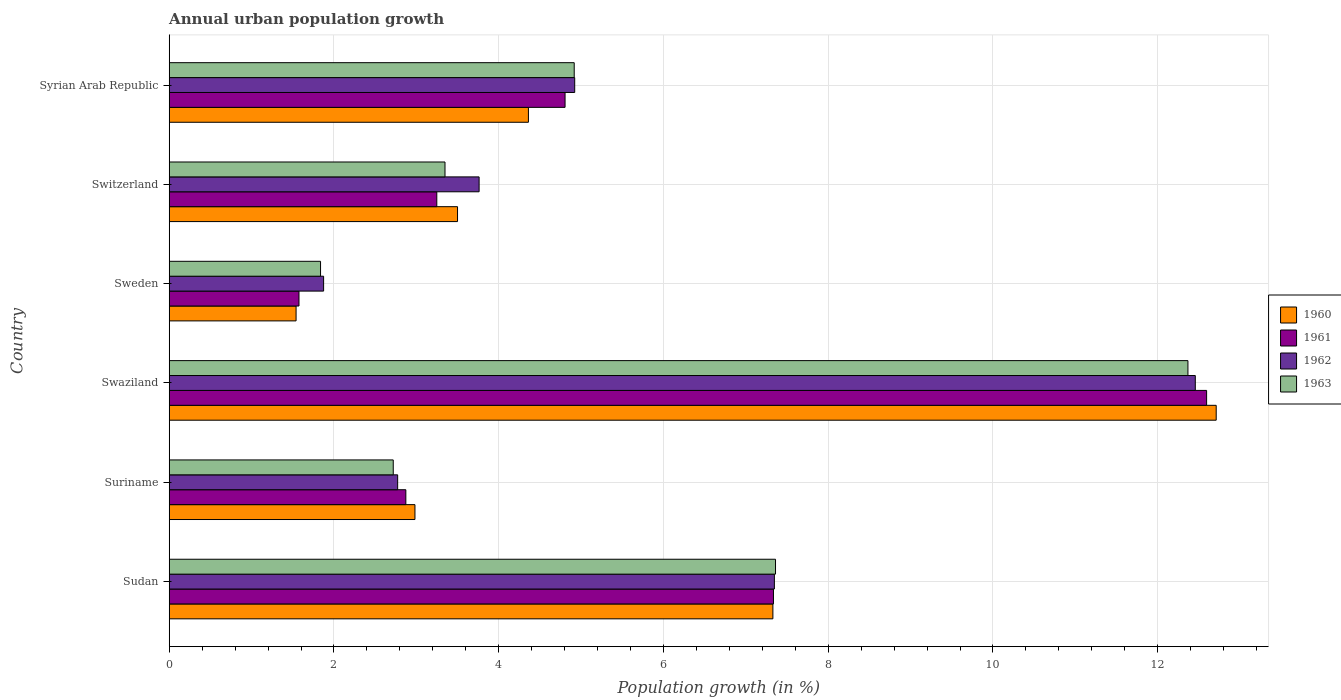Are the number of bars per tick equal to the number of legend labels?
Provide a succinct answer. Yes. How many bars are there on the 6th tick from the bottom?
Give a very brief answer. 4. What is the label of the 6th group of bars from the top?
Your answer should be compact. Sudan. What is the percentage of urban population growth in 1962 in Sweden?
Offer a very short reply. 1.87. Across all countries, what is the maximum percentage of urban population growth in 1963?
Ensure brevity in your answer.  12.37. Across all countries, what is the minimum percentage of urban population growth in 1962?
Your answer should be very brief. 1.87. In which country was the percentage of urban population growth in 1961 maximum?
Ensure brevity in your answer.  Swaziland. In which country was the percentage of urban population growth in 1960 minimum?
Provide a succinct answer. Sweden. What is the total percentage of urban population growth in 1960 in the graph?
Provide a succinct answer. 32.42. What is the difference between the percentage of urban population growth in 1963 in Suriname and that in Switzerland?
Your answer should be very brief. -0.63. What is the difference between the percentage of urban population growth in 1960 in Syrian Arab Republic and the percentage of urban population growth in 1963 in Swaziland?
Your answer should be very brief. -8.01. What is the average percentage of urban population growth in 1962 per country?
Offer a very short reply. 5.52. What is the difference between the percentage of urban population growth in 1962 and percentage of urban population growth in 1961 in Suriname?
Your response must be concise. -0.1. What is the ratio of the percentage of urban population growth in 1963 in Sudan to that in Syrian Arab Republic?
Give a very brief answer. 1.5. Is the percentage of urban population growth in 1961 in Sudan less than that in Swaziland?
Keep it short and to the point. Yes. What is the difference between the highest and the second highest percentage of urban population growth in 1963?
Make the answer very short. 5.01. What is the difference between the highest and the lowest percentage of urban population growth in 1962?
Offer a very short reply. 10.58. Is it the case that in every country, the sum of the percentage of urban population growth in 1962 and percentage of urban population growth in 1960 is greater than the percentage of urban population growth in 1961?
Provide a short and direct response. Yes. Are all the bars in the graph horizontal?
Give a very brief answer. Yes. How many countries are there in the graph?
Make the answer very short. 6. Are the values on the major ticks of X-axis written in scientific E-notation?
Your response must be concise. No. Does the graph contain any zero values?
Offer a terse response. No. How many legend labels are there?
Make the answer very short. 4. How are the legend labels stacked?
Offer a very short reply. Vertical. What is the title of the graph?
Your response must be concise. Annual urban population growth. What is the label or title of the X-axis?
Provide a succinct answer. Population growth (in %). What is the Population growth (in %) of 1960 in Sudan?
Your answer should be very brief. 7.33. What is the Population growth (in %) of 1961 in Sudan?
Your answer should be very brief. 7.34. What is the Population growth (in %) in 1962 in Sudan?
Your answer should be compact. 7.35. What is the Population growth (in %) of 1963 in Sudan?
Your answer should be very brief. 7.36. What is the Population growth (in %) of 1960 in Suriname?
Give a very brief answer. 2.98. What is the Population growth (in %) in 1961 in Suriname?
Offer a terse response. 2.87. What is the Population growth (in %) of 1962 in Suriname?
Offer a terse response. 2.77. What is the Population growth (in %) in 1963 in Suriname?
Make the answer very short. 2.72. What is the Population growth (in %) of 1960 in Swaziland?
Your answer should be compact. 12.71. What is the Population growth (in %) of 1961 in Swaziland?
Provide a succinct answer. 12.59. What is the Population growth (in %) in 1962 in Swaziland?
Your answer should be very brief. 12.46. What is the Population growth (in %) in 1963 in Swaziland?
Your response must be concise. 12.37. What is the Population growth (in %) of 1960 in Sweden?
Provide a short and direct response. 1.54. What is the Population growth (in %) in 1961 in Sweden?
Keep it short and to the point. 1.58. What is the Population growth (in %) in 1962 in Sweden?
Offer a terse response. 1.87. What is the Population growth (in %) in 1963 in Sweden?
Make the answer very short. 1.84. What is the Population growth (in %) in 1960 in Switzerland?
Offer a very short reply. 3.5. What is the Population growth (in %) of 1961 in Switzerland?
Offer a very short reply. 3.25. What is the Population growth (in %) in 1962 in Switzerland?
Provide a succinct answer. 3.76. What is the Population growth (in %) in 1963 in Switzerland?
Your answer should be compact. 3.35. What is the Population growth (in %) in 1960 in Syrian Arab Republic?
Offer a terse response. 4.36. What is the Population growth (in %) of 1961 in Syrian Arab Republic?
Provide a succinct answer. 4.81. What is the Population growth (in %) of 1962 in Syrian Arab Republic?
Give a very brief answer. 4.92. What is the Population growth (in %) of 1963 in Syrian Arab Republic?
Offer a terse response. 4.92. Across all countries, what is the maximum Population growth (in %) of 1960?
Your answer should be very brief. 12.71. Across all countries, what is the maximum Population growth (in %) in 1961?
Keep it short and to the point. 12.59. Across all countries, what is the maximum Population growth (in %) of 1962?
Ensure brevity in your answer.  12.46. Across all countries, what is the maximum Population growth (in %) of 1963?
Keep it short and to the point. 12.37. Across all countries, what is the minimum Population growth (in %) of 1960?
Your answer should be compact. 1.54. Across all countries, what is the minimum Population growth (in %) of 1961?
Give a very brief answer. 1.58. Across all countries, what is the minimum Population growth (in %) in 1962?
Provide a succinct answer. 1.87. Across all countries, what is the minimum Population growth (in %) of 1963?
Your answer should be very brief. 1.84. What is the total Population growth (in %) of 1960 in the graph?
Provide a short and direct response. 32.42. What is the total Population growth (in %) of 1961 in the graph?
Offer a terse response. 32.43. What is the total Population growth (in %) in 1962 in the graph?
Your answer should be very brief. 33.14. What is the total Population growth (in %) in 1963 in the graph?
Provide a short and direct response. 32.55. What is the difference between the Population growth (in %) in 1960 in Sudan and that in Suriname?
Provide a succinct answer. 4.35. What is the difference between the Population growth (in %) of 1961 in Sudan and that in Suriname?
Your answer should be very brief. 4.46. What is the difference between the Population growth (in %) in 1962 in Sudan and that in Suriname?
Keep it short and to the point. 4.57. What is the difference between the Population growth (in %) in 1963 in Sudan and that in Suriname?
Offer a terse response. 4.64. What is the difference between the Population growth (in %) in 1960 in Sudan and that in Swaziland?
Make the answer very short. -5.38. What is the difference between the Population growth (in %) of 1961 in Sudan and that in Swaziland?
Your answer should be very brief. -5.26. What is the difference between the Population growth (in %) of 1962 in Sudan and that in Swaziland?
Your answer should be compact. -5.11. What is the difference between the Population growth (in %) in 1963 in Sudan and that in Swaziland?
Provide a succinct answer. -5.01. What is the difference between the Population growth (in %) in 1960 in Sudan and that in Sweden?
Give a very brief answer. 5.79. What is the difference between the Population growth (in %) of 1961 in Sudan and that in Sweden?
Provide a short and direct response. 5.76. What is the difference between the Population growth (in %) in 1962 in Sudan and that in Sweden?
Offer a terse response. 5.47. What is the difference between the Population growth (in %) in 1963 in Sudan and that in Sweden?
Your response must be concise. 5.52. What is the difference between the Population growth (in %) of 1960 in Sudan and that in Switzerland?
Give a very brief answer. 3.83. What is the difference between the Population growth (in %) in 1961 in Sudan and that in Switzerland?
Keep it short and to the point. 4.09. What is the difference between the Population growth (in %) in 1962 in Sudan and that in Switzerland?
Provide a short and direct response. 3.58. What is the difference between the Population growth (in %) of 1963 in Sudan and that in Switzerland?
Offer a very short reply. 4.01. What is the difference between the Population growth (in %) in 1960 in Sudan and that in Syrian Arab Republic?
Provide a succinct answer. 2.97. What is the difference between the Population growth (in %) in 1961 in Sudan and that in Syrian Arab Republic?
Offer a terse response. 2.53. What is the difference between the Population growth (in %) of 1962 in Sudan and that in Syrian Arab Republic?
Give a very brief answer. 2.42. What is the difference between the Population growth (in %) in 1963 in Sudan and that in Syrian Arab Republic?
Provide a succinct answer. 2.44. What is the difference between the Population growth (in %) of 1960 in Suriname and that in Swaziland?
Your answer should be compact. -9.73. What is the difference between the Population growth (in %) in 1961 in Suriname and that in Swaziland?
Ensure brevity in your answer.  -9.72. What is the difference between the Population growth (in %) in 1962 in Suriname and that in Swaziland?
Provide a short and direct response. -9.68. What is the difference between the Population growth (in %) in 1963 in Suriname and that in Swaziland?
Your answer should be very brief. -9.65. What is the difference between the Population growth (in %) in 1960 in Suriname and that in Sweden?
Offer a very short reply. 1.44. What is the difference between the Population growth (in %) in 1961 in Suriname and that in Sweden?
Provide a short and direct response. 1.3. What is the difference between the Population growth (in %) in 1962 in Suriname and that in Sweden?
Offer a terse response. 0.9. What is the difference between the Population growth (in %) in 1963 in Suriname and that in Sweden?
Provide a short and direct response. 0.88. What is the difference between the Population growth (in %) in 1960 in Suriname and that in Switzerland?
Offer a very short reply. -0.52. What is the difference between the Population growth (in %) in 1961 in Suriname and that in Switzerland?
Offer a very short reply. -0.38. What is the difference between the Population growth (in %) in 1962 in Suriname and that in Switzerland?
Your response must be concise. -0.99. What is the difference between the Population growth (in %) in 1963 in Suriname and that in Switzerland?
Ensure brevity in your answer.  -0.63. What is the difference between the Population growth (in %) in 1960 in Suriname and that in Syrian Arab Republic?
Provide a succinct answer. -1.38. What is the difference between the Population growth (in %) of 1961 in Suriname and that in Syrian Arab Republic?
Your answer should be very brief. -1.93. What is the difference between the Population growth (in %) of 1962 in Suriname and that in Syrian Arab Republic?
Your answer should be very brief. -2.15. What is the difference between the Population growth (in %) in 1963 in Suriname and that in Syrian Arab Republic?
Give a very brief answer. -2.2. What is the difference between the Population growth (in %) of 1960 in Swaziland and that in Sweden?
Offer a very short reply. 11.17. What is the difference between the Population growth (in %) of 1961 in Swaziland and that in Sweden?
Give a very brief answer. 11.02. What is the difference between the Population growth (in %) of 1962 in Swaziland and that in Sweden?
Provide a short and direct response. 10.58. What is the difference between the Population growth (in %) of 1963 in Swaziland and that in Sweden?
Your answer should be very brief. 10.53. What is the difference between the Population growth (in %) in 1960 in Swaziland and that in Switzerland?
Ensure brevity in your answer.  9.21. What is the difference between the Population growth (in %) in 1961 in Swaziland and that in Switzerland?
Offer a very short reply. 9.35. What is the difference between the Population growth (in %) of 1962 in Swaziland and that in Switzerland?
Your response must be concise. 8.69. What is the difference between the Population growth (in %) in 1963 in Swaziland and that in Switzerland?
Ensure brevity in your answer.  9.02. What is the difference between the Population growth (in %) in 1960 in Swaziland and that in Syrian Arab Republic?
Offer a very short reply. 8.35. What is the difference between the Population growth (in %) of 1961 in Swaziland and that in Syrian Arab Republic?
Your answer should be very brief. 7.79. What is the difference between the Population growth (in %) of 1962 in Swaziland and that in Syrian Arab Republic?
Make the answer very short. 7.53. What is the difference between the Population growth (in %) in 1963 in Swaziland and that in Syrian Arab Republic?
Ensure brevity in your answer.  7.45. What is the difference between the Population growth (in %) of 1960 in Sweden and that in Switzerland?
Offer a very short reply. -1.96. What is the difference between the Population growth (in %) in 1961 in Sweden and that in Switzerland?
Your response must be concise. -1.67. What is the difference between the Population growth (in %) of 1962 in Sweden and that in Switzerland?
Give a very brief answer. -1.89. What is the difference between the Population growth (in %) of 1963 in Sweden and that in Switzerland?
Ensure brevity in your answer.  -1.51. What is the difference between the Population growth (in %) in 1960 in Sweden and that in Syrian Arab Republic?
Your answer should be compact. -2.82. What is the difference between the Population growth (in %) of 1961 in Sweden and that in Syrian Arab Republic?
Your response must be concise. -3.23. What is the difference between the Population growth (in %) of 1962 in Sweden and that in Syrian Arab Republic?
Give a very brief answer. -3.05. What is the difference between the Population growth (in %) of 1963 in Sweden and that in Syrian Arab Republic?
Your answer should be very brief. -3.08. What is the difference between the Population growth (in %) of 1960 in Switzerland and that in Syrian Arab Republic?
Make the answer very short. -0.86. What is the difference between the Population growth (in %) of 1961 in Switzerland and that in Syrian Arab Republic?
Give a very brief answer. -1.56. What is the difference between the Population growth (in %) in 1962 in Switzerland and that in Syrian Arab Republic?
Your response must be concise. -1.16. What is the difference between the Population growth (in %) in 1963 in Switzerland and that in Syrian Arab Republic?
Your answer should be compact. -1.57. What is the difference between the Population growth (in %) of 1960 in Sudan and the Population growth (in %) of 1961 in Suriname?
Give a very brief answer. 4.46. What is the difference between the Population growth (in %) in 1960 in Sudan and the Population growth (in %) in 1962 in Suriname?
Your response must be concise. 4.56. What is the difference between the Population growth (in %) of 1960 in Sudan and the Population growth (in %) of 1963 in Suriname?
Provide a succinct answer. 4.61. What is the difference between the Population growth (in %) of 1961 in Sudan and the Population growth (in %) of 1962 in Suriname?
Offer a very short reply. 4.56. What is the difference between the Population growth (in %) in 1961 in Sudan and the Population growth (in %) in 1963 in Suriname?
Your response must be concise. 4.62. What is the difference between the Population growth (in %) in 1962 in Sudan and the Population growth (in %) in 1963 in Suriname?
Your answer should be very brief. 4.63. What is the difference between the Population growth (in %) of 1960 in Sudan and the Population growth (in %) of 1961 in Swaziland?
Provide a succinct answer. -5.27. What is the difference between the Population growth (in %) of 1960 in Sudan and the Population growth (in %) of 1962 in Swaziland?
Your answer should be compact. -5.13. What is the difference between the Population growth (in %) in 1960 in Sudan and the Population growth (in %) in 1963 in Swaziland?
Offer a terse response. -5.04. What is the difference between the Population growth (in %) of 1961 in Sudan and the Population growth (in %) of 1962 in Swaziland?
Ensure brevity in your answer.  -5.12. What is the difference between the Population growth (in %) in 1961 in Sudan and the Population growth (in %) in 1963 in Swaziland?
Make the answer very short. -5.03. What is the difference between the Population growth (in %) in 1962 in Sudan and the Population growth (in %) in 1963 in Swaziland?
Your answer should be very brief. -5.02. What is the difference between the Population growth (in %) in 1960 in Sudan and the Population growth (in %) in 1961 in Sweden?
Make the answer very short. 5.75. What is the difference between the Population growth (in %) in 1960 in Sudan and the Population growth (in %) in 1962 in Sweden?
Your response must be concise. 5.45. What is the difference between the Population growth (in %) in 1960 in Sudan and the Population growth (in %) in 1963 in Sweden?
Keep it short and to the point. 5.49. What is the difference between the Population growth (in %) of 1961 in Sudan and the Population growth (in %) of 1962 in Sweden?
Ensure brevity in your answer.  5.46. What is the difference between the Population growth (in %) in 1961 in Sudan and the Population growth (in %) in 1963 in Sweden?
Offer a terse response. 5.5. What is the difference between the Population growth (in %) in 1962 in Sudan and the Population growth (in %) in 1963 in Sweden?
Give a very brief answer. 5.51. What is the difference between the Population growth (in %) of 1960 in Sudan and the Population growth (in %) of 1961 in Switzerland?
Your answer should be compact. 4.08. What is the difference between the Population growth (in %) of 1960 in Sudan and the Population growth (in %) of 1962 in Switzerland?
Ensure brevity in your answer.  3.57. What is the difference between the Population growth (in %) in 1960 in Sudan and the Population growth (in %) in 1963 in Switzerland?
Your answer should be compact. 3.98. What is the difference between the Population growth (in %) of 1961 in Sudan and the Population growth (in %) of 1962 in Switzerland?
Give a very brief answer. 3.57. What is the difference between the Population growth (in %) of 1961 in Sudan and the Population growth (in %) of 1963 in Switzerland?
Offer a terse response. 3.99. What is the difference between the Population growth (in %) in 1962 in Sudan and the Population growth (in %) in 1963 in Switzerland?
Keep it short and to the point. 4. What is the difference between the Population growth (in %) in 1960 in Sudan and the Population growth (in %) in 1961 in Syrian Arab Republic?
Provide a succinct answer. 2.52. What is the difference between the Population growth (in %) of 1960 in Sudan and the Population growth (in %) of 1962 in Syrian Arab Republic?
Offer a very short reply. 2.41. What is the difference between the Population growth (in %) in 1960 in Sudan and the Population growth (in %) in 1963 in Syrian Arab Republic?
Keep it short and to the point. 2.41. What is the difference between the Population growth (in %) in 1961 in Sudan and the Population growth (in %) in 1962 in Syrian Arab Republic?
Make the answer very short. 2.41. What is the difference between the Population growth (in %) of 1961 in Sudan and the Population growth (in %) of 1963 in Syrian Arab Republic?
Your response must be concise. 2.42. What is the difference between the Population growth (in %) in 1962 in Sudan and the Population growth (in %) in 1963 in Syrian Arab Republic?
Ensure brevity in your answer.  2.43. What is the difference between the Population growth (in %) in 1960 in Suriname and the Population growth (in %) in 1961 in Swaziland?
Ensure brevity in your answer.  -9.61. What is the difference between the Population growth (in %) of 1960 in Suriname and the Population growth (in %) of 1962 in Swaziland?
Your answer should be compact. -9.47. What is the difference between the Population growth (in %) of 1960 in Suriname and the Population growth (in %) of 1963 in Swaziland?
Ensure brevity in your answer.  -9.38. What is the difference between the Population growth (in %) of 1961 in Suriname and the Population growth (in %) of 1962 in Swaziland?
Your answer should be very brief. -9.58. What is the difference between the Population growth (in %) in 1961 in Suriname and the Population growth (in %) in 1963 in Swaziland?
Your answer should be very brief. -9.49. What is the difference between the Population growth (in %) in 1962 in Suriname and the Population growth (in %) in 1963 in Swaziland?
Provide a short and direct response. -9.59. What is the difference between the Population growth (in %) in 1960 in Suriname and the Population growth (in %) in 1961 in Sweden?
Provide a short and direct response. 1.41. What is the difference between the Population growth (in %) of 1960 in Suriname and the Population growth (in %) of 1962 in Sweden?
Give a very brief answer. 1.11. What is the difference between the Population growth (in %) in 1960 in Suriname and the Population growth (in %) in 1963 in Sweden?
Provide a short and direct response. 1.15. What is the difference between the Population growth (in %) of 1961 in Suriname and the Population growth (in %) of 1962 in Sweden?
Provide a succinct answer. 1. What is the difference between the Population growth (in %) in 1961 in Suriname and the Population growth (in %) in 1963 in Sweden?
Offer a very short reply. 1.04. What is the difference between the Population growth (in %) in 1962 in Suriname and the Population growth (in %) in 1963 in Sweden?
Offer a very short reply. 0.94. What is the difference between the Population growth (in %) of 1960 in Suriname and the Population growth (in %) of 1961 in Switzerland?
Provide a succinct answer. -0.27. What is the difference between the Population growth (in %) in 1960 in Suriname and the Population growth (in %) in 1962 in Switzerland?
Your response must be concise. -0.78. What is the difference between the Population growth (in %) of 1960 in Suriname and the Population growth (in %) of 1963 in Switzerland?
Keep it short and to the point. -0.36. What is the difference between the Population growth (in %) in 1961 in Suriname and the Population growth (in %) in 1962 in Switzerland?
Make the answer very short. -0.89. What is the difference between the Population growth (in %) of 1961 in Suriname and the Population growth (in %) of 1963 in Switzerland?
Offer a very short reply. -0.48. What is the difference between the Population growth (in %) in 1962 in Suriname and the Population growth (in %) in 1963 in Switzerland?
Provide a succinct answer. -0.57. What is the difference between the Population growth (in %) of 1960 in Suriname and the Population growth (in %) of 1961 in Syrian Arab Republic?
Your answer should be very brief. -1.82. What is the difference between the Population growth (in %) in 1960 in Suriname and the Population growth (in %) in 1962 in Syrian Arab Republic?
Your answer should be very brief. -1.94. What is the difference between the Population growth (in %) of 1960 in Suriname and the Population growth (in %) of 1963 in Syrian Arab Republic?
Ensure brevity in your answer.  -1.93. What is the difference between the Population growth (in %) of 1961 in Suriname and the Population growth (in %) of 1962 in Syrian Arab Republic?
Your answer should be compact. -2.05. What is the difference between the Population growth (in %) of 1961 in Suriname and the Population growth (in %) of 1963 in Syrian Arab Republic?
Offer a very short reply. -2.04. What is the difference between the Population growth (in %) of 1962 in Suriname and the Population growth (in %) of 1963 in Syrian Arab Republic?
Ensure brevity in your answer.  -2.14. What is the difference between the Population growth (in %) of 1960 in Swaziland and the Population growth (in %) of 1961 in Sweden?
Give a very brief answer. 11.13. What is the difference between the Population growth (in %) of 1960 in Swaziland and the Population growth (in %) of 1962 in Sweden?
Your answer should be very brief. 10.84. What is the difference between the Population growth (in %) in 1960 in Swaziland and the Population growth (in %) in 1963 in Sweden?
Your answer should be very brief. 10.87. What is the difference between the Population growth (in %) in 1961 in Swaziland and the Population growth (in %) in 1962 in Sweden?
Your answer should be compact. 10.72. What is the difference between the Population growth (in %) of 1961 in Swaziland and the Population growth (in %) of 1963 in Sweden?
Give a very brief answer. 10.76. What is the difference between the Population growth (in %) of 1962 in Swaziland and the Population growth (in %) of 1963 in Sweden?
Offer a very short reply. 10.62. What is the difference between the Population growth (in %) of 1960 in Swaziland and the Population growth (in %) of 1961 in Switzerland?
Give a very brief answer. 9.46. What is the difference between the Population growth (in %) of 1960 in Swaziland and the Population growth (in %) of 1962 in Switzerland?
Provide a succinct answer. 8.95. What is the difference between the Population growth (in %) of 1960 in Swaziland and the Population growth (in %) of 1963 in Switzerland?
Give a very brief answer. 9.36. What is the difference between the Population growth (in %) in 1961 in Swaziland and the Population growth (in %) in 1962 in Switzerland?
Provide a short and direct response. 8.83. What is the difference between the Population growth (in %) in 1961 in Swaziland and the Population growth (in %) in 1963 in Switzerland?
Your response must be concise. 9.25. What is the difference between the Population growth (in %) in 1962 in Swaziland and the Population growth (in %) in 1963 in Switzerland?
Your answer should be compact. 9.11. What is the difference between the Population growth (in %) in 1960 in Swaziland and the Population growth (in %) in 1961 in Syrian Arab Republic?
Offer a very short reply. 7.9. What is the difference between the Population growth (in %) in 1960 in Swaziland and the Population growth (in %) in 1962 in Syrian Arab Republic?
Provide a succinct answer. 7.79. What is the difference between the Population growth (in %) in 1960 in Swaziland and the Population growth (in %) in 1963 in Syrian Arab Republic?
Your answer should be very brief. 7.79. What is the difference between the Population growth (in %) of 1961 in Swaziland and the Population growth (in %) of 1962 in Syrian Arab Republic?
Give a very brief answer. 7.67. What is the difference between the Population growth (in %) in 1961 in Swaziland and the Population growth (in %) in 1963 in Syrian Arab Republic?
Your response must be concise. 7.68. What is the difference between the Population growth (in %) of 1962 in Swaziland and the Population growth (in %) of 1963 in Syrian Arab Republic?
Offer a terse response. 7.54. What is the difference between the Population growth (in %) of 1960 in Sweden and the Population growth (in %) of 1961 in Switzerland?
Your answer should be compact. -1.71. What is the difference between the Population growth (in %) of 1960 in Sweden and the Population growth (in %) of 1962 in Switzerland?
Ensure brevity in your answer.  -2.22. What is the difference between the Population growth (in %) of 1960 in Sweden and the Population growth (in %) of 1963 in Switzerland?
Provide a short and direct response. -1.81. What is the difference between the Population growth (in %) of 1961 in Sweden and the Population growth (in %) of 1962 in Switzerland?
Offer a very short reply. -2.19. What is the difference between the Population growth (in %) of 1961 in Sweden and the Population growth (in %) of 1963 in Switzerland?
Your response must be concise. -1.77. What is the difference between the Population growth (in %) of 1962 in Sweden and the Population growth (in %) of 1963 in Switzerland?
Provide a short and direct response. -1.47. What is the difference between the Population growth (in %) of 1960 in Sweden and the Population growth (in %) of 1961 in Syrian Arab Republic?
Your answer should be very brief. -3.27. What is the difference between the Population growth (in %) of 1960 in Sweden and the Population growth (in %) of 1962 in Syrian Arab Republic?
Make the answer very short. -3.38. What is the difference between the Population growth (in %) of 1960 in Sweden and the Population growth (in %) of 1963 in Syrian Arab Republic?
Your response must be concise. -3.38. What is the difference between the Population growth (in %) of 1961 in Sweden and the Population growth (in %) of 1962 in Syrian Arab Republic?
Provide a succinct answer. -3.35. What is the difference between the Population growth (in %) in 1961 in Sweden and the Population growth (in %) in 1963 in Syrian Arab Republic?
Give a very brief answer. -3.34. What is the difference between the Population growth (in %) in 1962 in Sweden and the Population growth (in %) in 1963 in Syrian Arab Republic?
Make the answer very short. -3.04. What is the difference between the Population growth (in %) of 1960 in Switzerland and the Population growth (in %) of 1961 in Syrian Arab Republic?
Your answer should be compact. -1.31. What is the difference between the Population growth (in %) in 1960 in Switzerland and the Population growth (in %) in 1962 in Syrian Arab Republic?
Give a very brief answer. -1.42. What is the difference between the Population growth (in %) in 1960 in Switzerland and the Population growth (in %) in 1963 in Syrian Arab Republic?
Make the answer very short. -1.42. What is the difference between the Population growth (in %) in 1961 in Switzerland and the Population growth (in %) in 1962 in Syrian Arab Republic?
Ensure brevity in your answer.  -1.67. What is the difference between the Population growth (in %) of 1961 in Switzerland and the Population growth (in %) of 1963 in Syrian Arab Republic?
Provide a succinct answer. -1.67. What is the difference between the Population growth (in %) in 1962 in Switzerland and the Population growth (in %) in 1963 in Syrian Arab Republic?
Provide a succinct answer. -1.15. What is the average Population growth (in %) of 1960 per country?
Give a very brief answer. 5.4. What is the average Population growth (in %) of 1961 per country?
Offer a terse response. 5.41. What is the average Population growth (in %) of 1962 per country?
Provide a succinct answer. 5.52. What is the average Population growth (in %) of 1963 per country?
Offer a very short reply. 5.42. What is the difference between the Population growth (in %) in 1960 and Population growth (in %) in 1961 in Sudan?
Your answer should be compact. -0.01. What is the difference between the Population growth (in %) of 1960 and Population growth (in %) of 1962 in Sudan?
Give a very brief answer. -0.02. What is the difference between the Population growth (in %) in 1960 and Population growth (in %) in 1963 in Sudan?
Make the answer very short. -0.03. What is the difference between the Population growth (in %) of 1961 and Population growth (in %) of 1962 in Sudan?
Make the answer very short. -0.01. What is the difference between the Population growth (in %) in 1961 and Population growth (in %) in 1963 in Sudan?
Keep it short and to the point. -0.02. What is the difference between the Population growth (in %) in 1962 and Population growth (in %) in 1963 in Sudan?
Provide a succinct answer. -0.01. What is the difference between the Population growth (in %) in 1960 and Population growth (in %) in 1961 in Suriname?
Keep it short and to the point. 0.11. What is the difference between the Population growth (in %) of 1960 and Population growth (in %) of 1962 in Suriname?
Provide a succinct answer. 0.21. What is the difference between the Population growth (in %) of 1960 and Population growth (in %) of 1963 in Suriname?
Offer a very short reply. 0.26. What is the difference between the Population growth (in %) of 1961 and Population growth (in %) of 1962 in Suriname?
Ensure brevity in your answer.  0.1. What is the difference between the Population growth (in %) of 1961 and Population growth (in %) of 1963 in Suriname?
Your answer should be very brief. 0.15. What is the difference between the Population growth (in %) in 1962 and Population growth (in %) in 1963 in Suriname?
Ensure brevity in your answer.  0.05. What is the difference between the Population growth (in %) in 1960 and Population growth (in %) in 1961 in Swaziland?
Your answer should be very brief. 0.12. What is the difference between the Population growth (in %) in 1960 and Population growth (in %) in 1962 in Swaziland?
Provide a short and direct response. 0.25. What is the difference between the Population growth (in %) of 1960 and Population growth (in %) of 1963 in Swaziland?
Ensure brevity in your answer.  0.34. What is the difference between the Population growth (in %) in 1961 and Population growth (in %) in 1962 in Swaziland?
Make the answer very short. 0.14. What is the difference between the Population growth (in %) of 1961 and Population growth (in %) of 1963 in Swaziland?
Offer a very short reply. 0.23. What is the difference between the Population growth (in %) in 1962 and Population growth (in %) in 1963 in Swaziland?
Ensure brevity in your answer.  0.09. What is the difference between the Population growth (in %) of 1960 and Population growth (in %) of 1961 in Sweden?
Your response must be concise. -0.04. What is the difference between the Population growth (in %) in 1960 and Population growth (in %) in 1962 in Sweden?
Offer a very short reply. -0.33. What is the difference between the Population growth (in %) in 1960 and Population growth (in %) in 1963 in Sweden?
Ensure brevity in your answer.  -0.3. What is the difference between the Population growth (in %) of 1961 and Population growth (in %) of 1962 in Sweden?
Your answer should be very brief. -0.3. What is the difference between the Population growth (in %) in 1961 and Population growth (in %) in 1963 in Sweden?
Your response must be concise. -0.26. What is the difference between the Population growth (in %) of 1962 and Population growth (in %) of 1963 in Sweden?
Give a very brief answer. 0.04. What is the difference between the Population growth (in %) in 1960 and Population growth (in %) in 1961 in Switzerland?
Give a very brief answer. 0.25. What is the difference between the Population growth (in %) in 1960 and Population growth (in %) in 1962 in Switzerland?
Give a very brief answer. -0.26. What is the difference between the Population growth (in %) in 1960 and Population growth (in %) in 1963 in Switzerland?
Provide a short and direct response. 0.15. What is the difference between the Population growth (in %) of 1961 and Population growth (in %) of 1962 in Switzerland?
Your response must be concise. -0.51. What is the difference between the Population growth (in %) of 1961 and Population growth (in %) of 1963 in Switzerland?
Your response must be concise. -0.1. What is the difference between the Population growth (in %) of 1962 and Population growth (in %) of 1963 in Switzerland?
Provide a short and direct response. 0.41. What is the difference between the Population growth (in %) in 1960 and Population growth (in %) in 1961 in Syrian Arab Republic?
Offer a very short reply. -0.44. What is the difference between the Population growth (in %) in 1960 and Population growth (in %) in 1962 in Syrian Arab Republic?
Ensure brevity in your answer.  -0.56. What is the difference between the Population growth (in %) in 1960 and Population growth (in %) in 1963 in Syrian Arab Republic?
Offer a very short reply. -0.56. What is the difference between the Population growth (in %) of 1961 and Population growth (in %) of 1962 in Syrian Arab Republic?
Make the answer very short. -0.12. What is the difference between the Population growth (in %) in 1961 and Population growth (in %) in 1963 in Syrian Arab Republic?
Offer a very short reply. -0.11. What is the difference between the Population growth (in %) of 1962 and Population growth (in %) of 1963 in Syrian Arab Republic?
Provide a short and direct response. 0.01. What is the ratio of the Population growth (in %) in 1960 in Sudan to that in Suriname?
Provide a short and direct response. 2.46. What is the ratio of the Population growth (in %) in 1961 in Sudan to that in Suriname?
Ensure brevity in your answer.  2.55. What is the ratio of the Population growth (in %) of 1962 in Sudan to that in Suriname?
Give a very brief answer. 2.65. What is the ratio of the Population growth (in %) of 1963 in Sudan to that in Suriname?
Ensure brevity in your answer.  2.71. What is the ratio of the Population growth (in %) in 1960 in Sudan to that in Swaziland?
Offer a terse response. 0.58. What is the ratio of the Population growth (in %) in 1961 in Sudan to that in Swaziland?
Your answer should be very brief. 0.58. What is the ratio of the Population growth (in %) in 1962 in Sudan to that in Swaziland?
Your response must be concise. 0.59. What is the ratio of the Population growth (in %) in 1963 in Sudan to that in Swaziland?
Give a very brief answer. 0.6. What is the ratio of the Population growth (in %) in 1960 in Sudan to that in Sweden?
Provide a succinct answer. 4.76. What is the ratio of the Population growth (in %) of 1961 in Sudan to that in Sweden?
Offer a terse response. 4.66. What is the ratio of the Population growth (in %) of 1962 in Sudan to that in Sweden?
Give a very brief answer. 3.92. What is the ratio of the Population growth (in %) of 1963 in Sudan to that in Sweden?
Your answer should be very brief. 4.01. What is the ratio of the Population growth (in %) in 1960 in Sudan to that in Switzerland?
Your response must be concise. 2.09. What is the ratio of the Population growth (in %) in 1961 in Sudan to that in Switzerland?
Provide a succinct answer. 2.26. What is the ratio of the Population growth (in %) of 1962 in Sudan to that in Switzerland?
Ensure brevity in your answer.  1.95. What is the ratio of the Population growth (in %) of 1963 in Sudan to that in Switzerland?
Your response must be concise. 2.2. What is the ratio of the Population growth (in %) in 1960 in Sudan to that in Syrian Arab Republic?
Ensure brevity in your answer.  1.68. What is the ratio of the Population growth (in %) in 1961 in Sudan to that in Syrian Arab Republic?
Provide a short and direct response. 1.53. What is the ratio of the Population growth (in %) of 1962 in Sudan to that in Syrian Arab Republic?
Offer a very short reply. 1.49. What is the ratio of the Population growth (in %) of 1963 in Sudan to that in Syrian Arab Republic?
Keep it short and to the point. 1.5. What is the ratio of the Population growth (in %) of 1960 in Suriname to that in Swaziland?
Provide a short and direct response. 0.23. What is the ratio of the Population growth (in %) in 1961 in Suriname to that in Swaziland?
Offer a terse response. 0.23. What is the ratio of the Population growth (in %) in 1962 in Suriname to that in Swaziland?
Make the answer very short. 0.22. What is the ratio of the Population growth (in %) of 1963 in Suriname to that in Swaziland?
Provide a succinct answer. 0.22. What is the ratio of the Population growth (in %) of 1960 in Suriname to that in Sweden?
Provide a short and direct response. 1.94. What is the ratio of the Population growth (in %) in 1961 in Suriname to that in Sweden?
Your answer should be very brief. 1.82. What is the ratio of the Population growth (in %) of 1962 in Suriname to that in Sweden?
Offer a very short reply. 1.48. What is the ratio of the Population growth (in %) in 1963 in Suriname to that in Sweden?
Your answer should be very brief. 1.48. What is the ratio of the Population growth (in %) in 1960 in Suriname to that in Switzerland?
Ensure brevity in your answer.  0.85. What is the ratio of the Population growth (in %) of 1961 in Suriname to that in Switzerland?
Offer a terse response. 0.88. What is the ratio of the Population growth (in %) of 1962 in Suriname to that in Switzerland?
Give a very brief answer. 0.74. What is the ratio of the Population growth (in %) of 1963 in Suriname to that in Switzerland?
Provide a succinct answer. 0.81. What is the ratio of the Population growth (in %) of 1960 in Suriname to that in Syrian Arab Republic?
Make the answer very short. 0.68. What is the ratio of the Population growth (in %) of 1961 in Suriname to that in Syrian Arab Republic?
Your response must be concise. 0.6. What is the ratio of the Population growth (in %) of 1962 in Suriname to that in Syrian Arab Republic?
Give a very brief answer. 0.56. What is the ratio of the Population growth (in %) in 1963 in Suriname to that in Syrian Arab Republic?
Keep it short and to the point. 0.55. What is the ratio of the Population growth (in %) in 1960 in Swaziland to that in Sweden?
Your answer should be compact. 8.25. What is the ratio of the Population growth (in %) in 1961 in Swaziland to that in Sweden?
Provide a short and direct response. 7.99. What is the ratio of the Population growth (in %) in 1962 in Swaziland to that in Sweden?
Keep it short and to the point. 6.65. What is the ratio of the Population growth (in %) in 1963 in Swaziland to that in Sweden?
Ensure brevity in your answer.  6.73. What is the ratio of the Population growth (in %) of 1960 in Swaziland to that in Switzerland?
Give a very brief answer. 3.63. What is the ratio of the Population growth (in %) of 1961 in Swaziland to that in Switzerland?
Keep it short and to the point. 3.88. What is the ratio of the Population growth (in %) of 1962 in Swaziland to that in Switzerland?
Your answer should be very brief. 3.31. What is the ratio of the Population growth (in %) in 1963 in Swaziland to that in Switzerland?
Provide a succinct answer. 3.69. What is the ratio of the Population growth (in %) of 1960 in Swaziland to that in Syrian Arab Republic?
Your answer should be very brief. 2.91. What is the ratio of the Population growth (in %) in 1961 in Swaziland to that in Syrian Arab Republic?
Your answer should be very brief. 2.62. What is the ratio of the Population growth (in %) in 1962 in Swaziland to that in Syrian Arab Republic?
Your response must be concise. 2.53. What is the ratio of the Population growth (in %) in 1963 in Swaziland to that in Syrian Arab Republic?
Offer a very short reply. 2.52. What is the ratio of the Population growth (in %) in 1960 in Sweden to that in Switzerland?
Provide a short and direct response. 0.44. What is the ratio of the Population growth (in %) in 1961 in Sweden to that in Switzerland?
Your response must be concise. 0.48. What is the ratio of the Population growth (in %) in 1962 in Sweden to that in Switzerland?
Provide a short and direct response. 0.5. What is the ratio of the Population growth (in %) of 1963 in Sweden to that in Switzerland?
Your answer should be very brief. 0.55. What is the ratio of the Population growth (in %) in 1960 in Sweden to that in Syrian Arab Republic?
Your answer should be very brief. 0.35. What is the ratio of the Population growth (in %) in 1961 in Sweden to that in Syrian Arab Republic?
Ensure brevity in your answer.  0.33. What is the ratio of the Population growth (in %) in 1962 in Sweden to that in Syrian Arab Republic?
Make the answer very short. 0.38. What is the ratio of the Population growth (in %) in 1963 in Sweden to that in Syrian Arab Republic?
Provide a short and direct response. 0.37. What is the ratio of the Population growth (in %) in 1960 in Switzerland to that in Syrian Arab Republic?
Your answer should be very brief. 0.8. What is the ratio of the Population growth (in %) of 1961 in Switzerland to that in Syrian Arab Republic?
Your response must be concise. 0.68. What is the ratio of the Population growth (in %) in 1962 in Switzerland to that in Syrian Arab Republic?
Offer a terse response. 0.76. What is the ratio of the Population growth (in %) of 1963 in Switzerland to that in Syrian Arab Republic?
Provide a succinct answer. 0.68. What is the difference between the highest and the second highest Population growth (in %) of 1960?
Make the answer very short. 5.38. What is the difference between the highest and the second highest Population growth (in %) in 1961?
Your response must be concise. 5.26. What is the difference between the highest and the second highest Population growth (in %) of 1962?
Provide a short and direct response. 5.11. What is the difference between the highest and the second highest Population growth (in %) in 1963?
Your answer should be very brief. 5.01. What is the difference between the highest and the lowest Population growth (in %) of 1960?
Offer a terse response. 11.17. What is the difference between the highest and the lowest Population growth (in %) in 1961?
Provide a succinct answer. 11.02. What is the difference between the highest and the lowest Population growth (in %) in 1962?
Make the answer very short. 10.58. What is the difference between the highest and the lowest Population growth (in %) of 1963?
Provide a short and direct response. 10.53. 